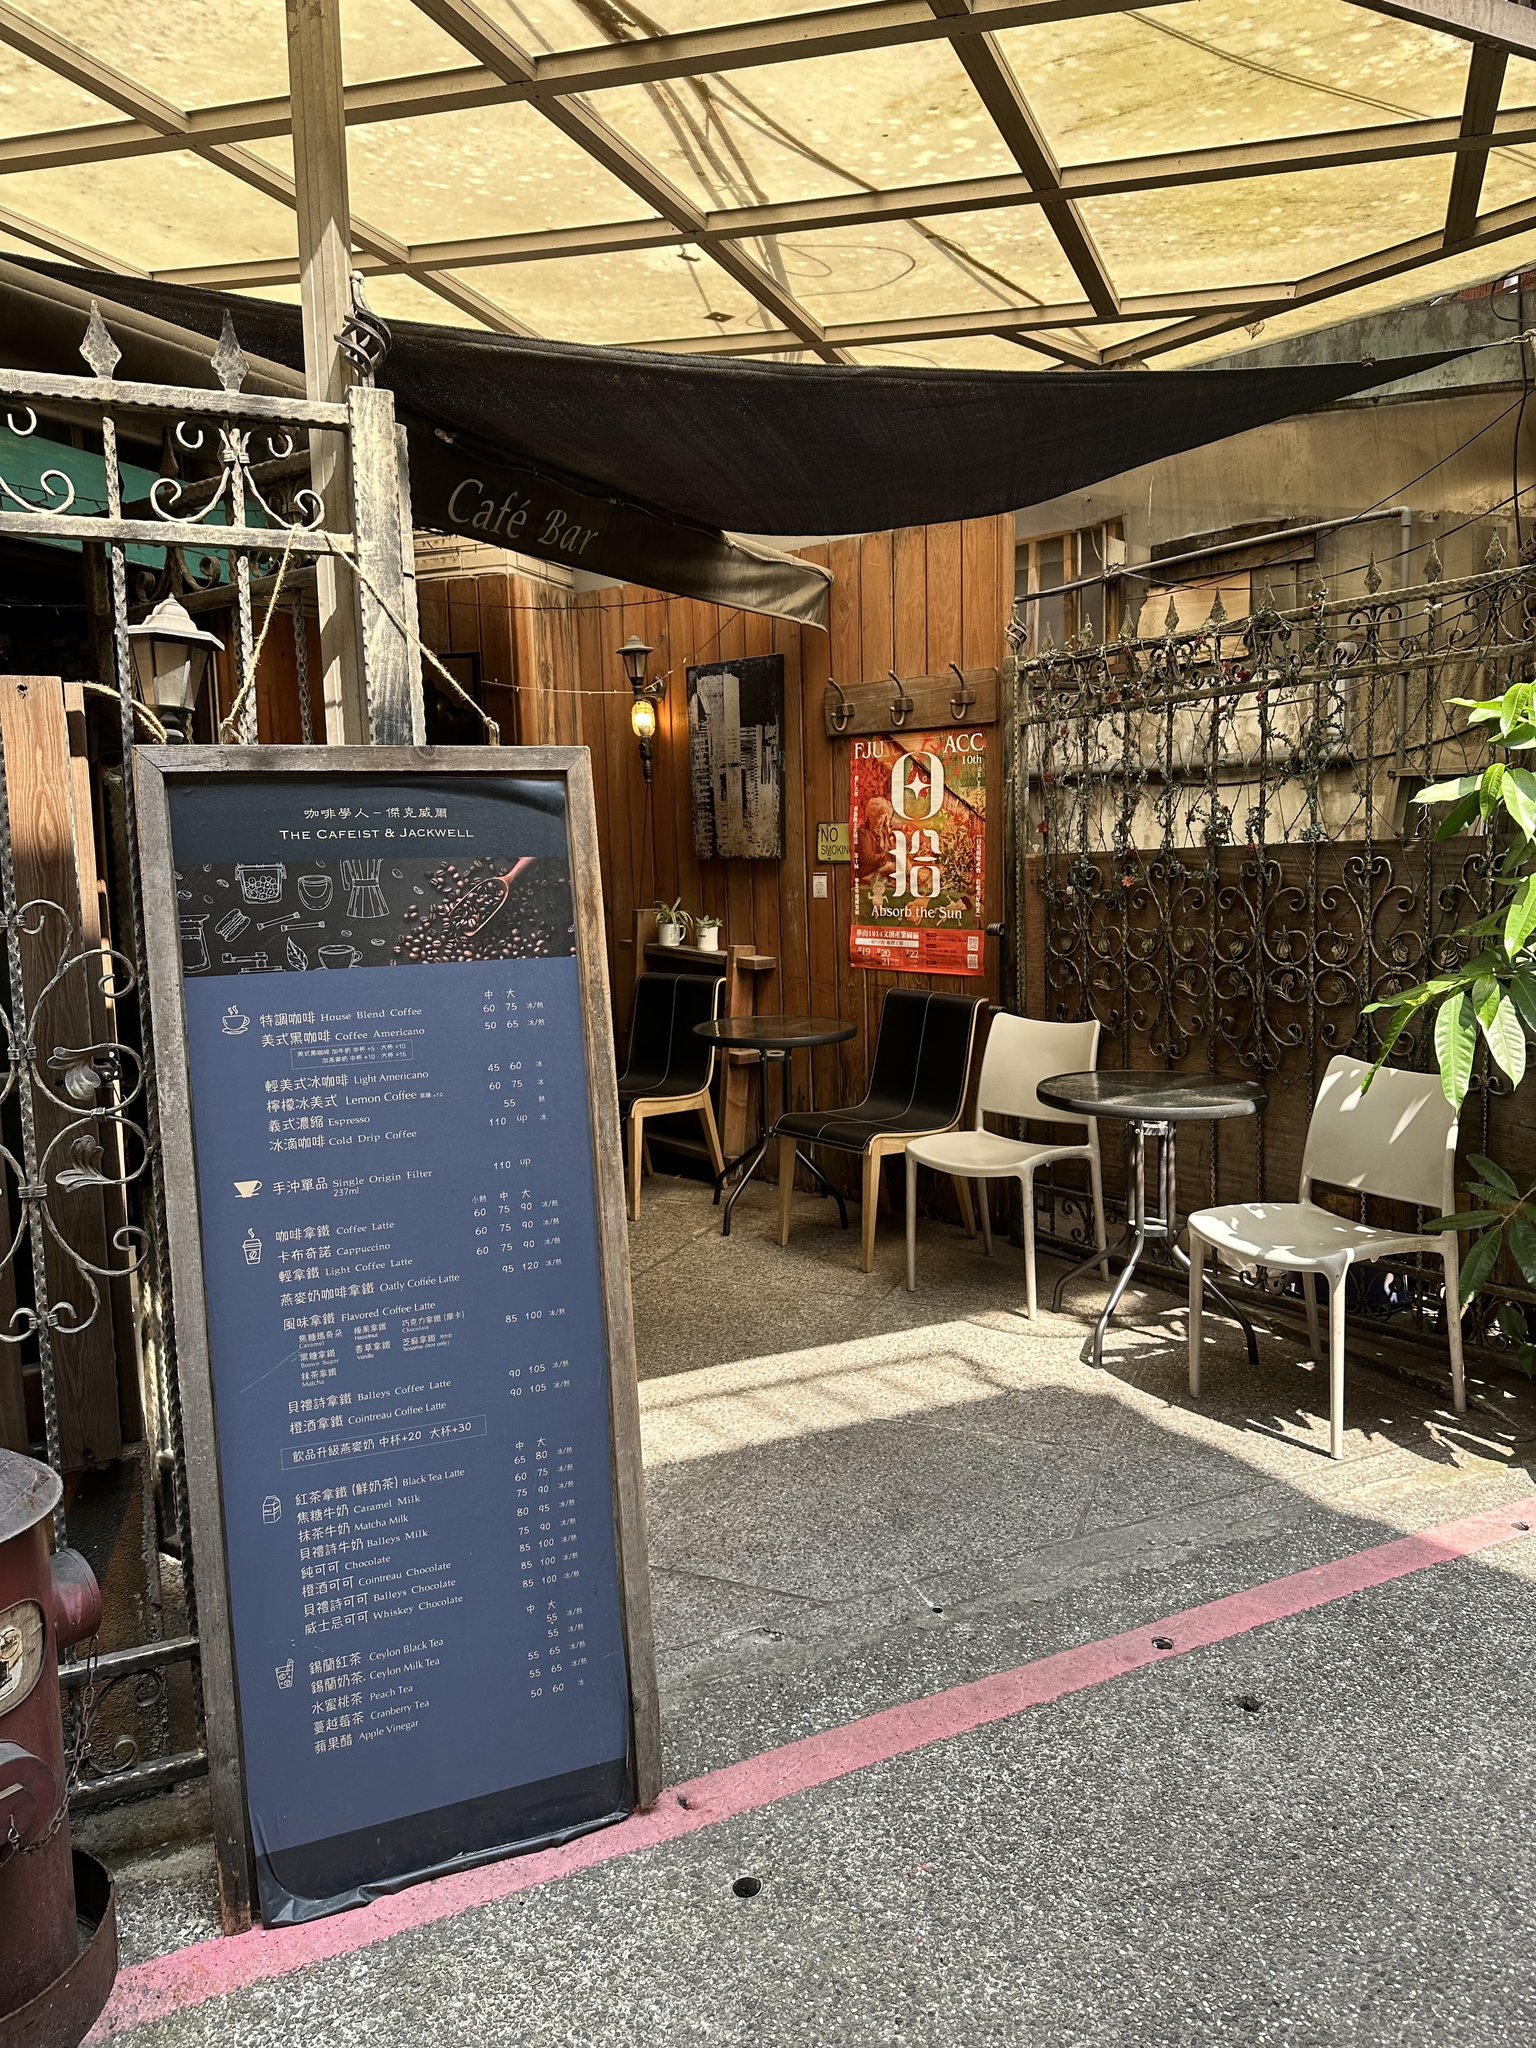How much does a medium hot latte cost? According to the menu board shown in the image, a medium Hot Latte at this cafe costs NT $85. 